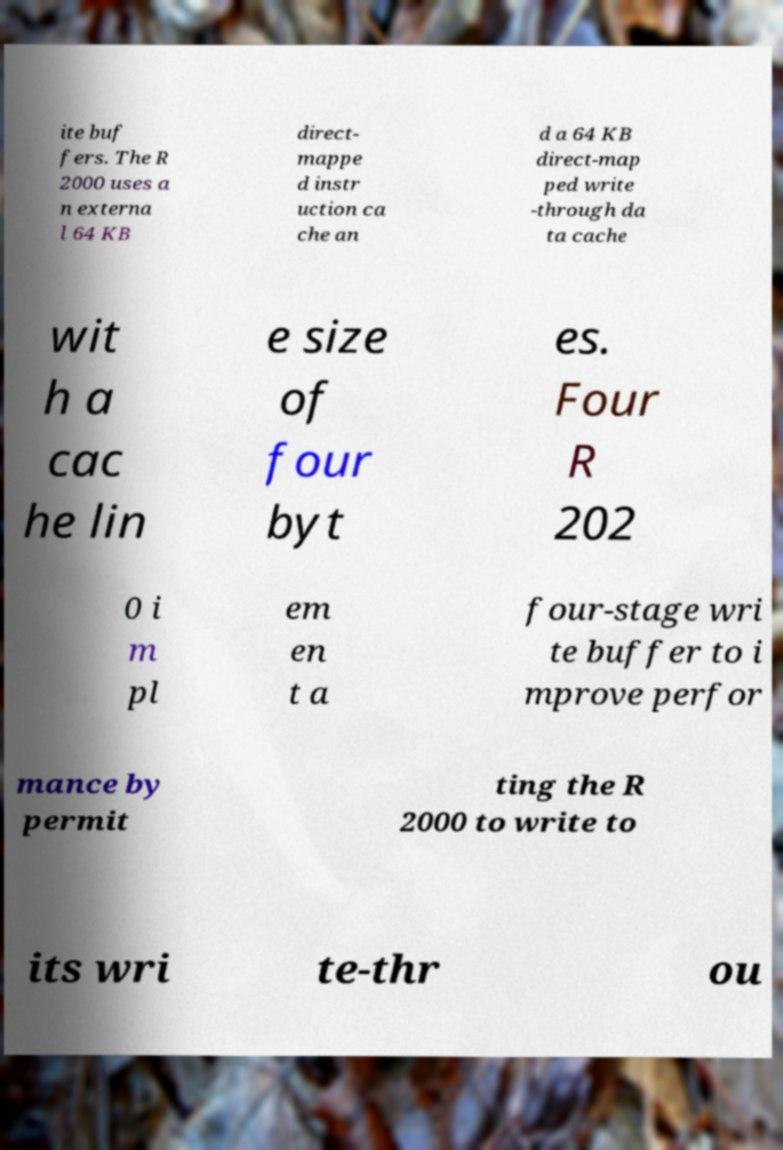There's text embedded in this image that I need extracted. Can you transcribe it verbatim? ite buf fers. The R 2000 uses a n externa l 64 KB direct- mappe d instr uction ca che an d a 64 KB direct-map ped write -through da ta cache wit h a cac he lin e size of four byt es. Four R 202 0 i m pl em en t a four-stage wri te buffer to i mprove perfor mance by permit ting the R 2000 to write to its wri te-thr ou 